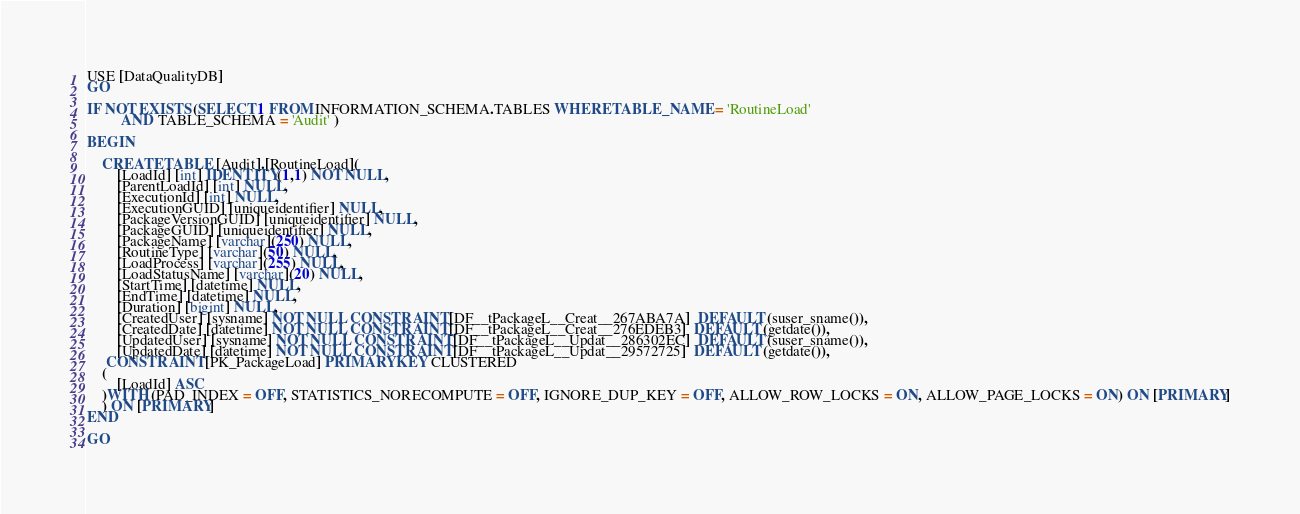Convert code to text. <code><loc_0><loc_0><loc_500><loc_500><_SQL_>USE [DataQualityDB]
GO

IF NOT EXISTS (SELECT 1 FROM INFORMATION_SCHEMA.TABLES WHERE TABLE_NAME = 'RoutineLoad'
		 AND TABLE_SCHEMA = 'Audit' ) 

BEGIN

	CREATE TABLE [Audit].[RoutineLoad](
		[LoadId] [int] IDENTITY(1,1) NOT NULL,
		[ParentLoadId] [int] NULL,
		[ExecutionId] [int] NULL,
		[ExecutionGUID] [uniqueidentifier] NULL,
		[PackageVersionGUID] [uniqueidentifier] NULL,
		[PackageGUID] [uniqueidentifier] NULL,
		[PackageName] [varchar](250) NULL,
		[RoutineType] [varchar](50) NULL,
		[LoadProcess] [varchar](255) NULL,
		[LoadStatusName] [varchar](20) NULL,
		[StartTime] [datetime] NULL,
		[EndTime] [datetime] NULL,
		[Duration] [bigint] NULL,
		[CreatedUser] [sysname] NOT NULL CONSTRAINT [DF__tPackageL__Creat__267ABA7A]  DEFAULT (suser_sname()),
		[CreatedDate] [datetime] NOT NULL CONSTRAINT [DF__tPackageL__Creat__276EDEB3]  DEFAULT (getdate()),
		[UpdatedUser] [sysname] NOT NULL CONSTRAINT [DF__tPackageL__Updat__286302EC]  DEFAULT (suser_sname()),
		[UpdatedDate] [datetime] NOT NULL CONSTRAINT [DF__tPackageL__Updat__29572725]  DEFAULT (getdate()),
	 CONSTRAINT [PK_PackageLoad] PRIMARY KEY CLUSTERED 
	(
		[LoadId] ASC
	)WITH (PAD_INDEX = OFF, STATISTICS_NORECOMPUTE = OFF, IGNORE_DUP_KEY = OFF, ALLOW_ROW_LOCKS = ON, ALLOW_PAGE_LOCKS = ON) ON [PRIMARY]
	) ON [PRIMARY]
END

GO</code> 